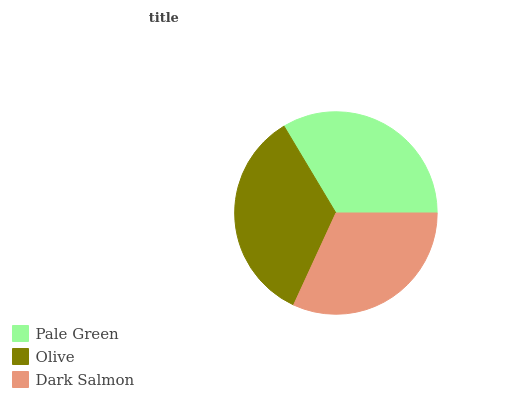Is Dark Salmon the minimum?
Answer yes or no. Yes. Is Olive the maximum?
Answer yes or no. Yes. Is Olive the minimum?
Answer yes or no. No. Is Dark Salmon the maximum?
Answer yes or no. No. Is Olive greater than Dark Salmon?
Answer yes or no. Yes. Is Dark Salmon less than Olive?
Answer yes or no. Yes. Is Dark Salmon greater than Olive?
Answer yes or no. No. Is Olive less than Dark Salmon?
Answer yes or no. No. Is Pale Green the high median?
Answer yes or no. Yes. Is Pale Green the low median?
Answer yes or no. Yes. Is Dark Salmon the high median?
Answer yes or no. No. Is Olive the low median?
Answer yes or no. No. 